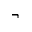<formula> <loc_0><loc_0><loc_500><loc_500>\neg</formula> 